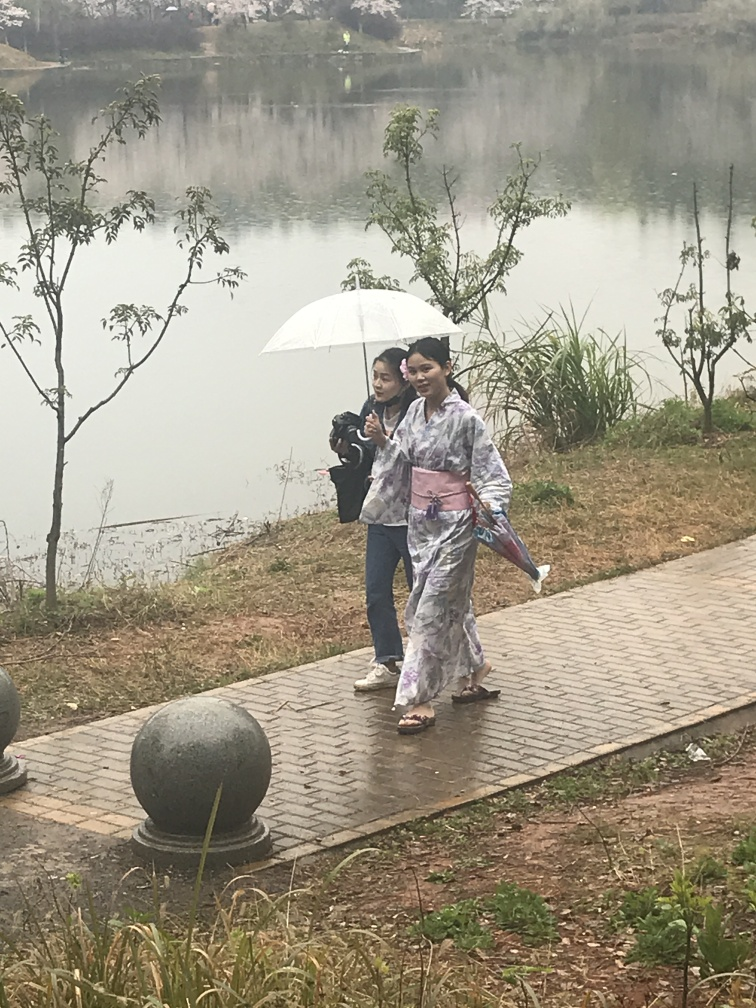What activity could the people in the image possibly be engaging in? It seems they are enjoying a leisurely stroll in a scenic environment. The person with the camera might be taking photographs either of the landscape or of the person in the traditional outfit, indicating an interest in capturing memories of the place or the traditional attire. 